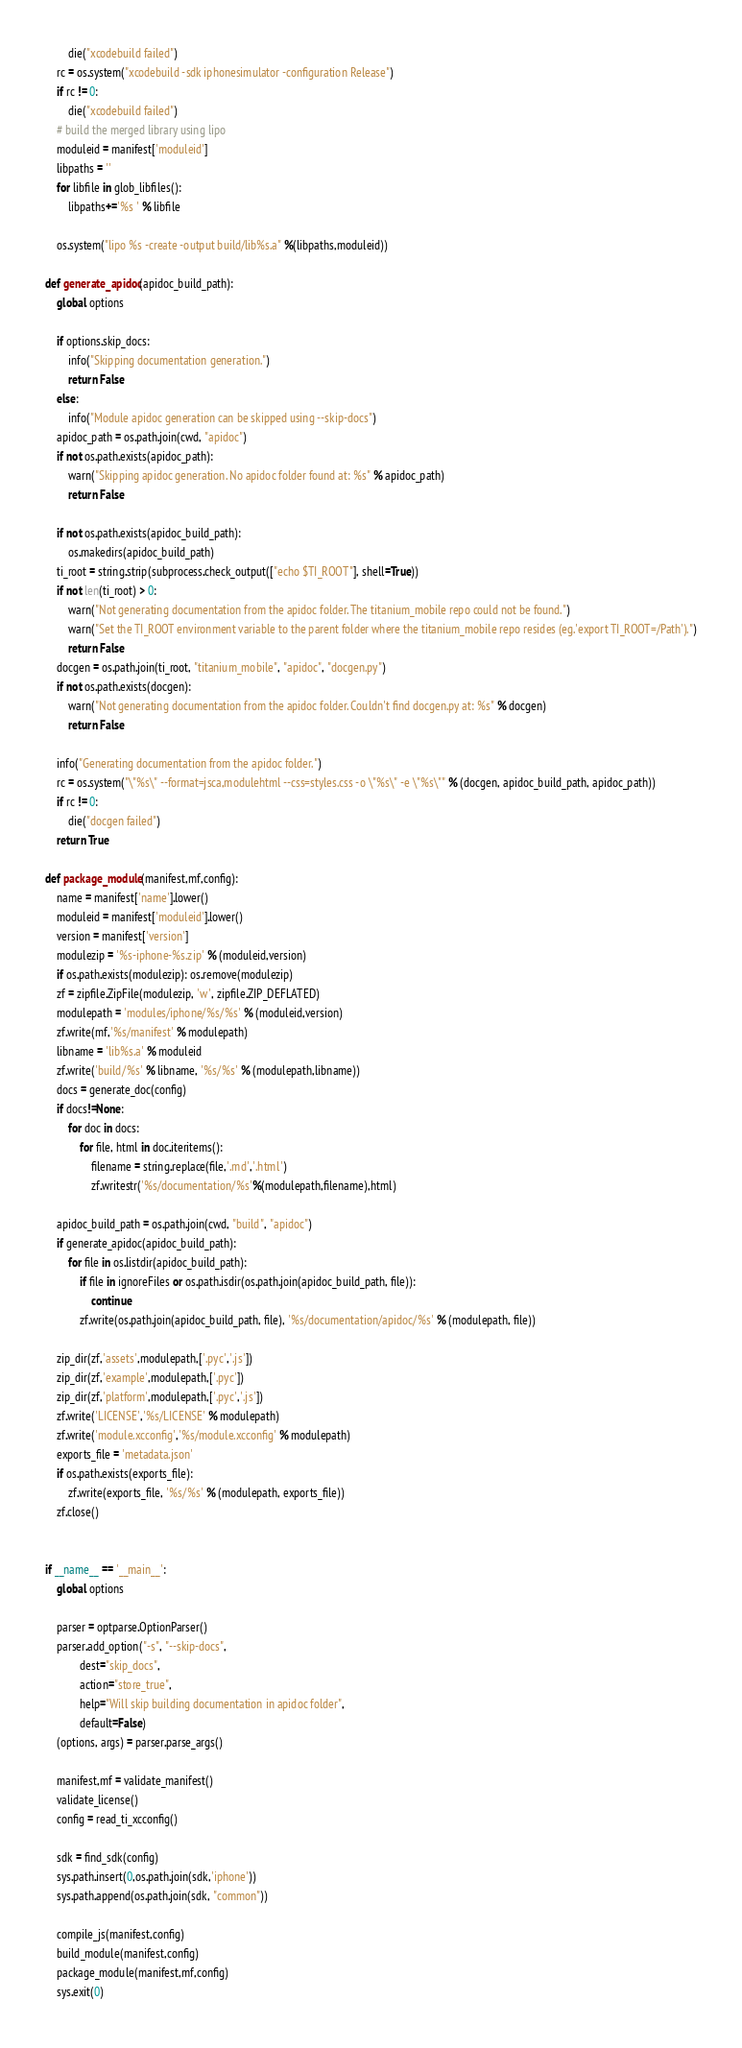<code> <loc_0><loc_0><loc_500><loc_500><_Python_>		die("xcodebuild failed")
	rc = os.system("xcodebuild -sdk iphonesimulator -configuration Release")
	if rc != 0:
		die("xcodebuild failed")
    # build the merged library using lipo
	moduleid = manifest['moduleid']
	libpaths = ''
	for libfile in glob_libfiles():
		libpaths+='%s ' % libfile

	os.system("lipo %s -create -output build/lib%s.a" %(libpaths,moduleid))
	
def generate_apidoc(apidoc_build_path):
	global options
	
	if options.skip_docs:
		info("Skipping documentation generation.")
		return False
	else:
		info("Module apidoc generation can be skipped using --skip-docs")
	apidoc_path = os.path.join(cwd, "apidoc")
	if not os.path.exists(apidoc_path):
		warn("Skipping apidoc generation. No apidoc folder found at: %s" % apidoc_path)
		return False
		
	if not os.path.exists(apidoc_build_path):
	    os.makedirs(apidoc_build_path)
	ti_root = string.strip(subprocess.check_output(["echo $TI_ROOT"], shell=True))
	if not len(ti_root) > 0:
		warn("Not generating documentation from the apidoc folder. The titanium_mobile repo could not be found.")
		warn("Set the TI_ROOT environment variable to the parent folder where the titanium_mobile repo resides (eg.'export TI_ROOT=/Path').")
		return False
	docgen = os.path.join(ti_root, "titanium_mobile", "apidoc", "docgen.py")
	if not os.path.exists(docgen):
		warn("Not generating documentation from the apidoc folder. Couldn't find docgen.py at: %s" % docgen)
		return False
		
	info("Generating documentation from the apidoc folder.")
	rc = os.system("\"%s\" --format=jsca,modulehtml --css=styles.css -o \"%s\" -e \"%s\"" % (docgen, apidoc_build_path, apidoc_path))
	if rc != 0:
		die("docgen failed")
	return True

def package_module(manifest,mf,config):
	name = manifest['name'].lower()
	moduleid = manifest['moduleid'].lower()
	version = manifest['version']
	modulezip = '%s-iphone-%s.zip' % (moduleid,version)
	if os.path.exists(modulezip): os.remove(modulezip)
	zf = zipfile.ZipFile(modulezip, 'w', zipfile.ZIP_DEFLATED)
	modulepath = 'modules/iphone/%s/%s' % (moduleid,version)
	zf.write(mf,'%s/manifest' % modulepath)
	libname = 'lib%s.a' % moduleid
	zf.write('build/%s' % libname, '%s/%s' % (modulepath,libname))
	docs = generate_doc(config)
	if docs!=None:
		for doc in docs:
			for file, html in doc.iteritems():
				filename = string.replace(file,'.md','.html')
				zf.writestr('%s/documentation/%s'%(modulepath,filename),html)
				
	apidoc_build_path = os.path.join(cwd, "build", "apidoc")
	if generate_apidoc(apidoc_build_path):
		for file in os.listdir(apidoc_build_path):
			if file in ignoreFiles or os.path.isdir(os.path.join(apidoc_build_path, file)):
				continue
			zf.write(os.path.join(apidoc_build_path, file), '%s/documentation/apidoc/%s' % (modulepath, file))
	
	zip_dir(zf,'assets',modulepath,['.pyc','.js'])
	zip_dir(zf,'example',modulepath,['.pyc'])
	zip_dir(zf,'platform',modulepath,['.pyc','.js'])
	zf.write('LICENSE','%s/LICENSE' % modulepath)
	zf.write('module.xcconfig','%s/module.xcconfig' % modulepath)
	exports_file = 'metadata.json'
	if os.path.exists(exports_file):
		zf.write(exports_file, '%s/%s' % (modulepath, exports_file))
	zf.close()


if __name__ == '__main__':
	global options
	
	parser = optparse.OptionParser()
	parser.add_option("-s", "--skip-docs",
			dest="skip_docs",
			action="store_true",
			help="Will skip building documentation in apidoc folder",
			default=False)
	(options, args) = parser.parse_args()
	
	manifest,mf = validate_manifest()
	validate_license()
	config = read_ti_xcconfig()

	sdk = find_sdk(config)
	sys.path.insert(0,os.path.join(sdk,'iphone'))
	sys.path.append(os.path.join(sdk, "common"))

	compile_js(manifest,config)
	build_module(manifest,config)
	package_module(manifest,mf,config)
	sys.exit(0)

</code> 